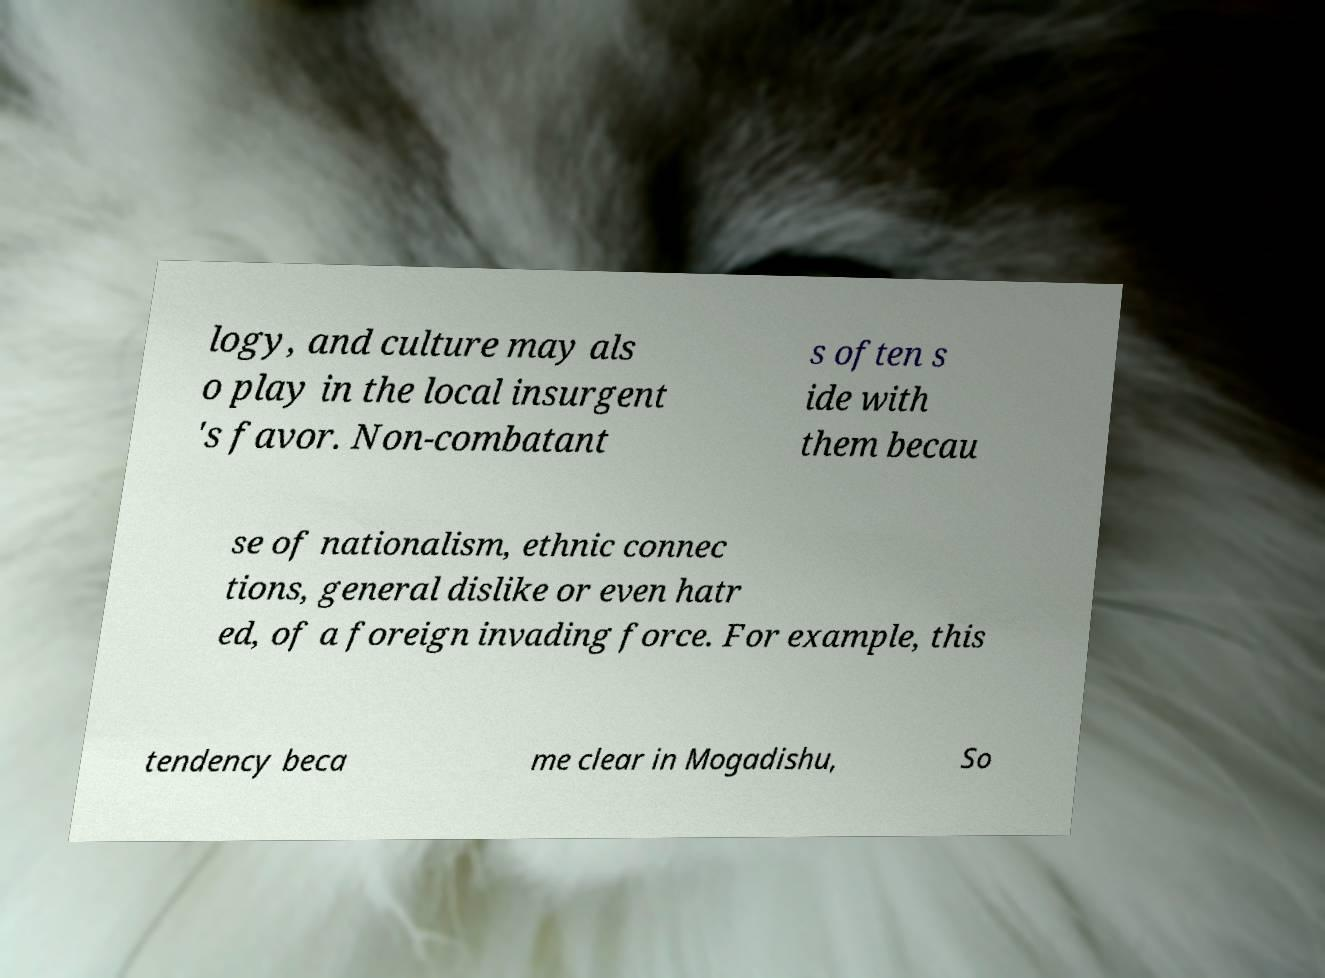There's text embedded in this image that I need extracted. Can you transcribe it verbatim? logy, and culture may als o play in the local insurgent 's favor. Non-combatant s often s ide with them becau se of nationalism, ethnic connec tions, general dislike or even hatr ed, of a foreign invading force. For example, this tendency beca me clear in Mogadishu, So 